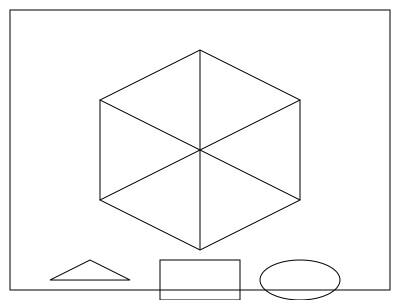As a cognitive behavioral therapist working with patients who have spatial anxiety, you're developing an exercise to help them visualize 3D objects. The image shows a 3D object and three possible cross-sections. Which cross-section would be correct if the object was cut horizontally at its midpoint? To solve this problem, we need to analyze the 3D object and visualize its cross-section at the midpoint. Let's break it down step-by-step:

1. Observe the 3D object: It appears to be a square-based pyramid or a similar shape with a square base that tapers to a point at the top.

2. Identify the midpoint: The midpoint would be halfway between the base and the top of the object.

3. Visualize the cross-section: At the midpoint, the cross-section would be a horizontal slice through the object.

4. Analyze the possible cross-sections:
   a) Triangle: This would be correct if we cut near the top of the object.
   b) Rectangle: This is the correct answer. At the midpoint, we would get a square (which is a type of rectangle) because we're cutting through the middle of the pyramid-like shape.
   c) Ellipse: This shape doesn't correspond to any possible horizontal cross-section of the given object.

5. Consider the therapeutic implications: This exercise helps patients with spatial anxiety by breaking down complex 3D visualizations into simpler 2D representations, potentially reducing anxiety associated with spatial tasks.

Therefore, the correct cross-section at the midpoint of the object would be the rectangle (square).
Answer: Rectangle 